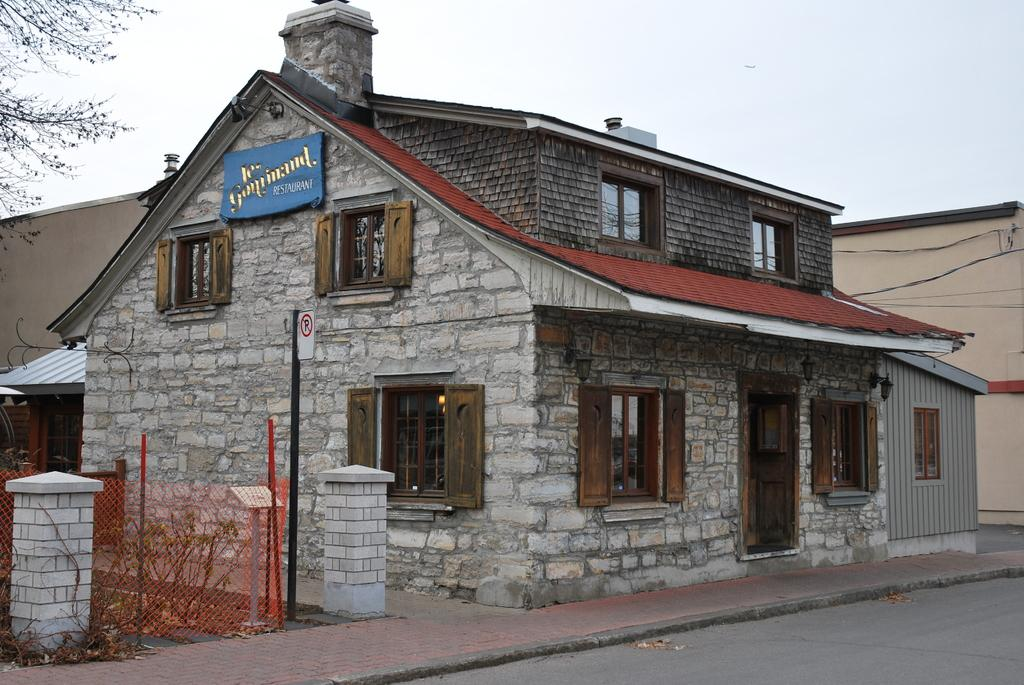What type of structures can be seen in the image? There are houses in the image. What else can be seen in the image besides the houses? There are wires, plants, pillars, poles, a tree, a path, and a road visible in the image. What is the natural element present in the image? There is a tree in the image. What is the man-made element present in the image? There is a path and a road visible in the image. What is visible at the top of the image? The sky is visible in the image. How many cats are playing on the bike in the image? There is no bike or cats present in the image. What hour is it in the image? The image does not provide any information about the time of day, so it is not possible to determine the hour. 